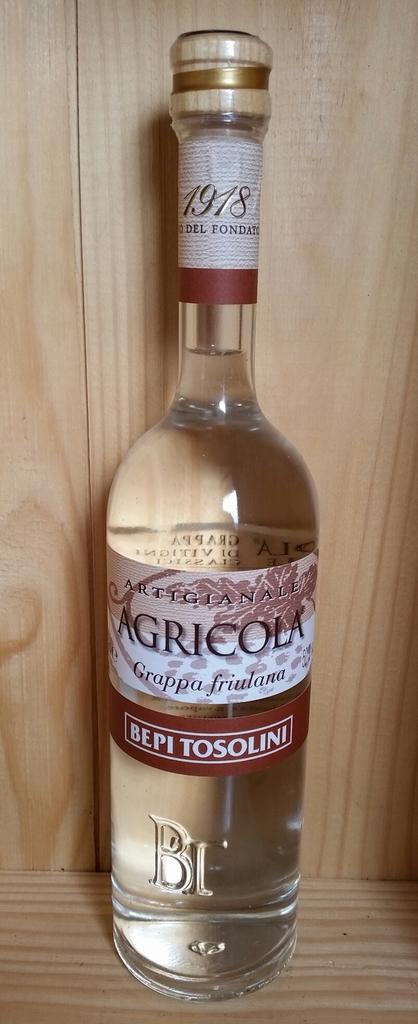What kind of drink is this?
Provide a succinct answer. Grappa. When was the drink made?
Ensure brevity in your answer.  1918. 